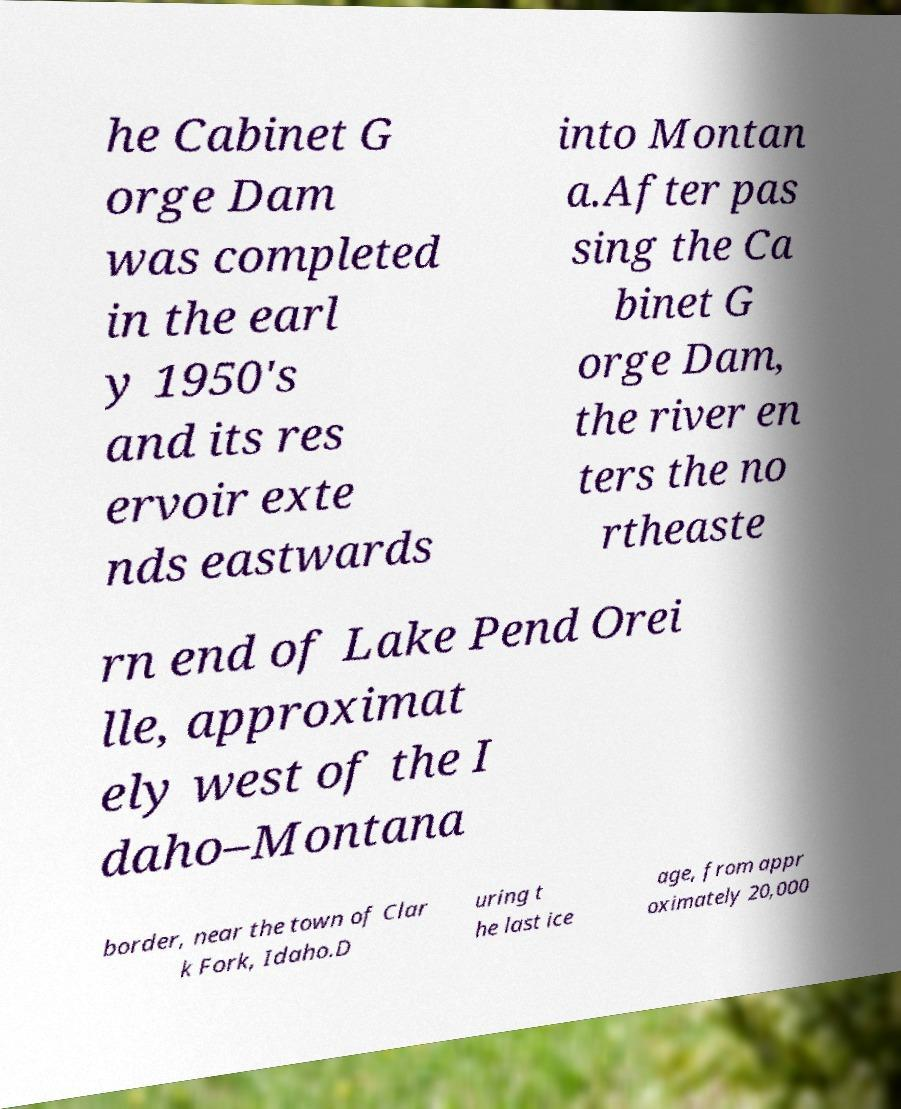Can you accurately transcribe the text from the provided image for me? he Cabinet G orge Dam was completed in the earl y 1950's and its res ervoir exte nds eastwards into Montan a.After pas sing the Ca binet G orge Dam, the river en ters the no rtheaste rn end of Lake Pend Orei lle, approximat ely west of the I daho–Montana border, near the town of Clar k Fork, Idaho.D uring t he last ice age, from appr oximately 20,000 